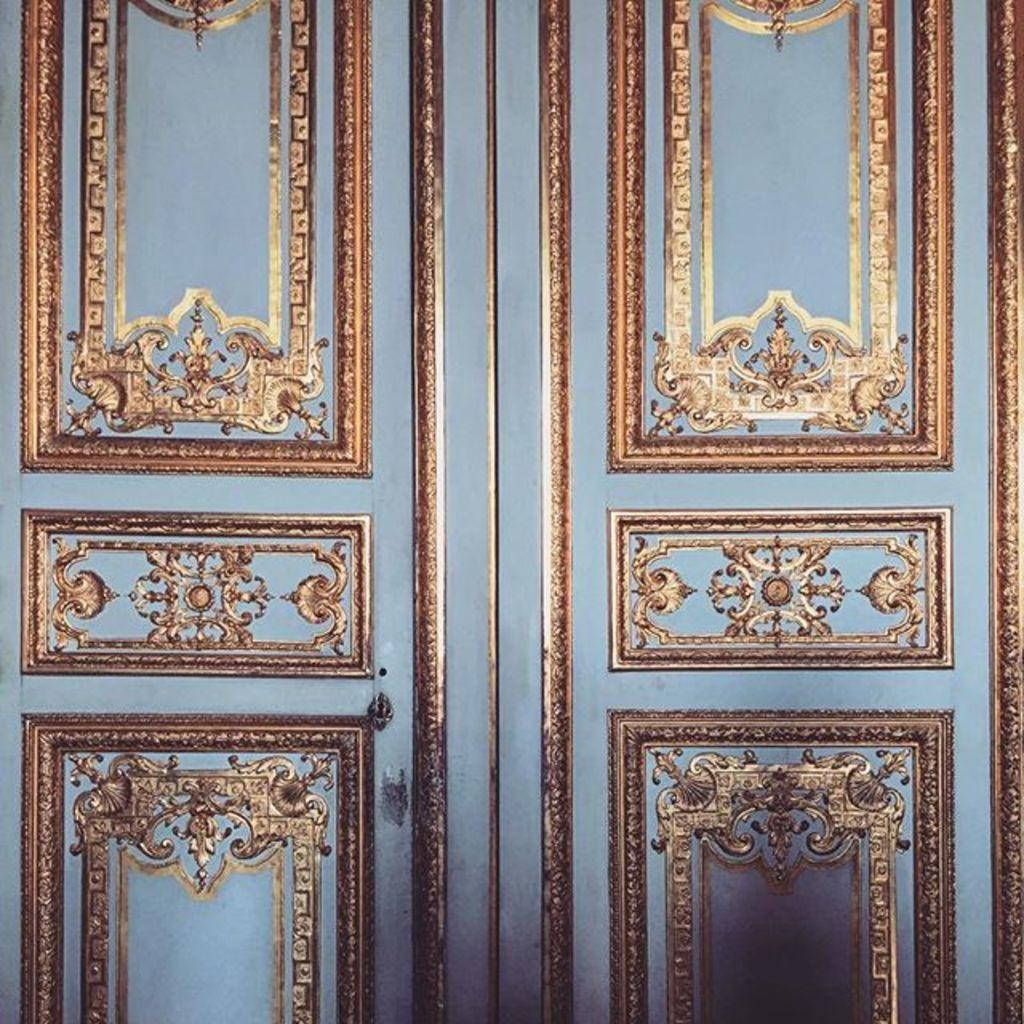What can be observed on the surface in the image? There are designs on the surface in the image. What is the income of the person who created the designs in the image? There is no information about the person who created the designs or their income in the image. 